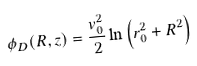Convert formula to latex. <formula><loc_0><loc_0><loc_500><loc_500>\phi _ { D } ( R , z ) = \frac { v _ { 0 } ^ { 2 } } { 2 } \ln \left ( r _ { 0 } ^ { 2 } + R ^ { 2 } \right )</formula> 